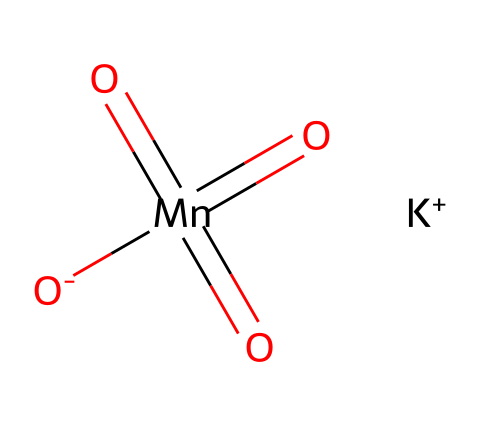How many oxygen atoms are present in potassium permanganate? The SMILES representation shows four oxygen atoms associated with manganese: one as an oxo group (double bonded) and three as oxo groups (two double-bonded and one single-bonded to the manganese). Thus, counting them gives a total of four oxygen atoms.
Answer: four What element is the central atom in the structure of potassium permanganate? The chemical structure indicates that manganese is the central atom, as it is represented by "Mn" in the SMILES. It also has multiple bonds with oxygen atoms surrounding it.
Answer: manganese How many total bonds are formed by the manganese atom? Manganese in this structure has four bonds: three double bonds and one single bond convert to double-bonded oxo groups. Counting the bonds yields a total of four.
Answer: four What is the oxidation state of manganese in potassium permanganate? In potassium permanganate, manganese has an oxidation state of +7, which can be deduced by considering its bonding with oxygen, where each oxo group contributes to the high oxidation state.
Answer: +7 Which part of potassium permanganate is responsible for its oxidative properties? The presence of manganese in a high oxidation state (+7) and its ability to destabilize reactants leads to its oxidative properties, making it a strong oxidizer.
Answer: manganese How is potassium permanganate generally used in rehabilitation centers? Potassium permanganate is commonly used in water treatment systems due to its strong oxidizing properties, which help to disinfect and purify water effectively.
Answer: water treatment What type of compound is potassium permanganate classified as? Potassium permanganate is classified as an oxidizer because of its ability to accept electrons during chemical reactions, which is a defining characteristic of oxidizing agents.
Answer: oxidizer 